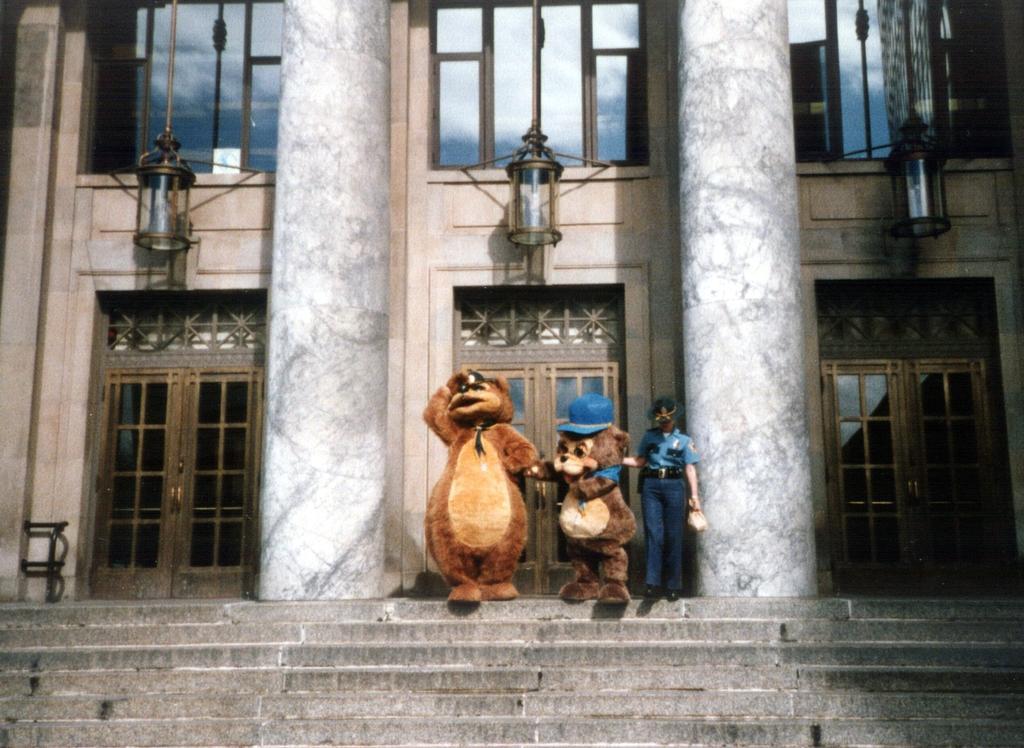Please provide a concise description of this image. In this image, in the middle there are two cartoon toys and a person. At the bottom there is a staircase. In the background there is a building, windows, glasses, lamps, doors, pillars and a wall. 